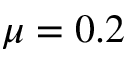<formula> <loc_0><loc_0><loc_500><loc_500>\mu = 0 . 2</formula> 